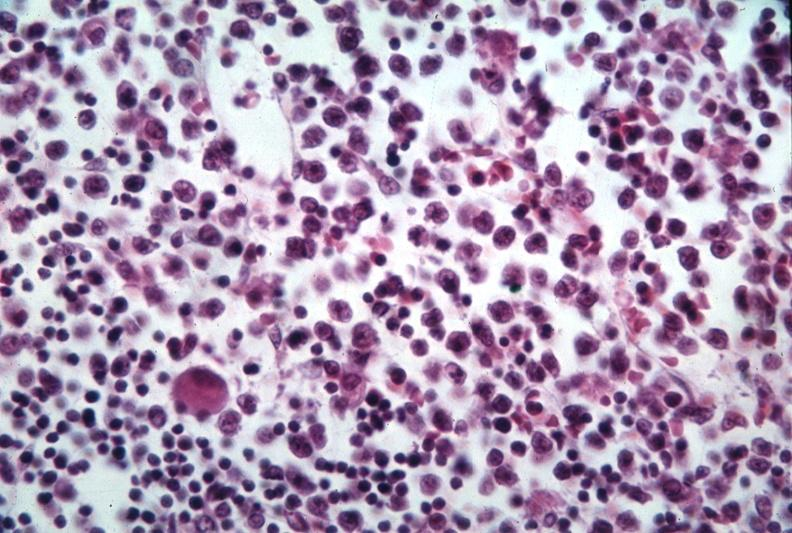s lymphangiomatosis present?
Answer the question using a single word or phrase. No 